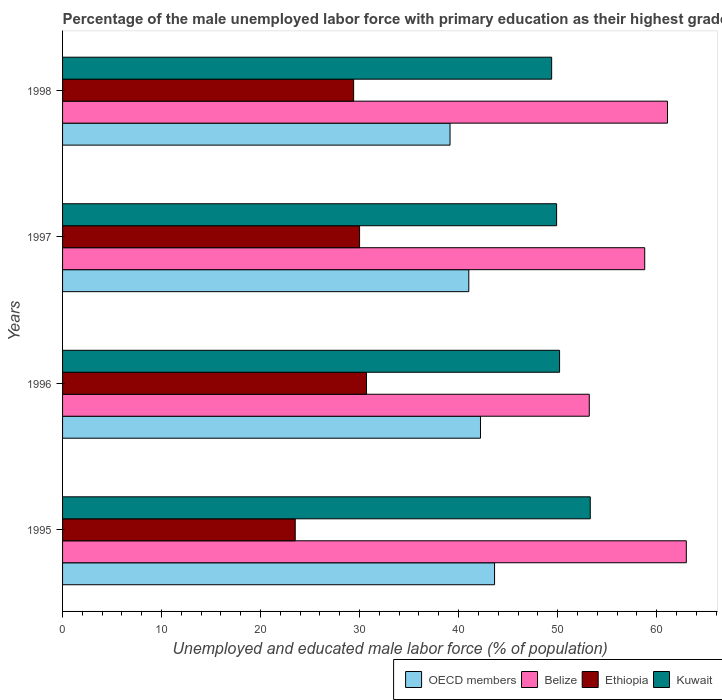Are the number of bars on each tick of the Y-axis equal?
Offer a very short reply. Yes. How many bars are there on the 3rd tick from the bottom?
Make the answer very short. 4. Across all years, what is the maximum percentage of the unemployed male labor force with primary education in OECD members?
Provide a short and direct response. 43.63. Across all years, what is the minimum percentage of the unemployed male labor force with primary education in Belize?
Ensure brevity in your answer.  53.2. What is the total percentage of the unemployed male labor force with primary education in OECD members in the graph?
Your response must be concise. 166.01. What is the difference between the percentage of the unemployed male labor force with primary education in Belize in 1996 and that in 1998?
Provide a succinct answer. -7.9. What is the difference between the percentage of the unemployed male labor force with primary education in Ethiopia in 1995 and the percentage of the unemployed male labor force with primary education in Kuwait in 1998?
Provide a succinct answer. -25.9. What is the average percentage of the unemployed male labor force with primary education in Belize per year?
Make the answer very short. 59.02. In the year 1998, what is the difference between the percentage of the unemployed male labor force with primary education in Kuwait and percentage of the unemployed male labor force with primary education in Belize?
Your answer should be very brief. -11.7. What is the ratio of the percentage of the unemployed male labor force with primary education in Kuwait in 1995 to that in 1996?
Your answer should be very brief. 1.06. What is the difference between the highest and the second highest percentage of the unemployed male labor force with primary education in OECD members?
Your answer should be very brief. 1.42. What is the difference between the highest and the lowest percentage of the unemployed male labor force with primary education in Kuwait?
Make the answer very short. 3.9. Is the sum of the percentage of the unemployed male labor force with primary education in Ethiopia in 1995 and 1997 greater than the maximum percentage of the unemployed male labor force with primary education in OECD members across all years?
Give a very brief answer. Yes. Is it the case that in every year, the sum of the percentage of the unemployed male labor force with primary education in Kuwait and percentage of the unemployed male labor force with primary education in Belize is greater than the sum of percentage of the unemployed male labor force with primary education in Ethiopia and percentage of the unemployed male labor force with primary education in OECD members?
Offer a very short reply. No. What does the 3rd bar from the top in 1998 represents?
Your answer should be very brief. Belize. What does the 1st bar from the bottom in 1998 represents?
Offer a very short reply. OECD members. Where does the legend appear in the graph?
Provide a short and direct response. Bottom right. What is the title of the graph?
Your answer should be compact. Percentage of the male unemployed labor force with primary education as their highest grade. Does "Georgia" appear as one of the legend labels in the graph?
Offer a terse response. No. What is the label or title of the X-axis?
Offer a terse response. Unemployed and educated male labor force (% of population). What is the label or title of the Y-axis?
Provide a short and direct response. Years. What is the Unemployed and educated male labor force (% of population) of OECD members in 1995?
Give a very brief answer. 43.63. What is the Unemployed and educated male labor force (% of population) of Kuwait in 1995?
Provide a short and direct response. 53.3. What is the Unemployed and educated male labor force (% of population) of OECD members in 1996?
Keep it short and to the point. 42.21. What is the Unemployed and educated male labor force (% of population) in Belize in 1996?
Provide a succinct answer. 53.2. What is the Unemployed and educated male labor force (% of population) in Ethiopia in 1996?
Provide a short and direct response. 30.7. What is the Unemployed and educated male labor force (% of population) of Kuwait in 1996?
Your response must be concise. 50.2. What is the Unemployed and educated male labor force (% of population) of OECD members in 1997?
Give a very brief answer. 41.03. What is the Unemployed and educated male labor force (% of population) of Belize in 1997?
Keep it short and to the point. 58.8. What is the Unemployed and educated male labor force (% of population) of Kuwait in 1997?
Keep it short and to the point. 49.9. What is the Unemployed and educated male labor force (% of population) in OECD members in 1998?
Provide a succinct answer. 39.14. What is the Unemployed and educated male labor force (% of population) of Belize in 1998?
Offer a very short reply. 61.1. What is the Unemployed and educated male labor force (% of population) of Ethiopia in 1998?
Keep it short and to the point. 29.4. What is the Unemployed and educated male labor force (% of population) in Kuwait in 1998?
Offer a very short reply. 49.4. Across all years, what is the maximum Unemployed and educated male labor force (% of population) in OECD members?
Provide a succinct answer. 43.63. Across all years, what is the maximum Unemployed and educated male labor force (% of population) in Ethiopia?
Keep it short and to the point. 30.7. Across all years, what is the maximum Unemployed and educated male labor force (% of population) of Kuwait?
Offer a very short reply. 53.3. Across all years, what is the minimum Unemployed and educated male labor force (% of population) in OECD members?
Ensure brevity in your answer.  39.14. Across all years, what is the minimum Unemployed and educated male labor force (% of population) of Belize?
Your answer should be compact. 53.2. Across all years, what is the minimum Unemployed and educated male labor force (% of population) in Ethiopia?
Offer a terse response. 23.5. Across all years, what is the minimum Unemployed and educated male labor force (% of population) in Kuwait?
Your answer should be compact. 49.4. What is the total Unemployed and educated male labor force (% of population) of OECD members in the graph?
Your response must be concise. 166.01. What is the total Unemployed and educated male labor force (% of population) in Belize in the graph?
Provide a short and direct response. 236.1. What is the total Unemployed and educated male labor force (% of population) of Ethiopia in the graph?
Make the answer very short. 113.6. What is the total Unemployed and educated male labor force (% of population) in Kuwait in the graph?
Offer a very short reply. 202.8. What is the difference between the Unemployed and educated male labor force (% of population) of OECD members in 1995 and that in 1996?
Give a very brief answer. 1.42. What is the difference between the Unemployed and educated male labor force (% of population) of Belize in 1995 and that in 1996?
Your response must be concise. 9.8. What is the difference between the Unemployed and educated male labor force (% of population) in OECD members in 1995 and that in 1997?
Your response must be concise. 2.6. What is the difference between the Unemployed and educated male labor force (% of population) of Kuwait in 1995 and that in 1997?
Keep it short and to the point. 3.4. What is the difference between the Unemployed and educated male labor force (% of population) of OECD members in 1995 and that in 1998?
Provide a short and direct response. 4.5. What is the difference between the Unemployed and educated male labor force (% of population) of Belize in 1995 and that in 1998?
Offer a terse response. 1.9. What is the difference between the Unemployed and educated male labor force (% of population) of OECD members in 1996 and that in 1997?
Keep it short and to the point. 1.18. What is the difference between the Unemployed and educated male labor force (% of population) of Ethiopia in 1996 and that in 1997?
Ensure brevity in your answer.  0.7. What is the difference between the Unemployed and educated male labor force (% of population) of OECD members in 1996 and that in 1998?
Your answer should be very brief. 3.07. What is the difference between the Unemployed and educated male labor force (% of population) of Belize in 1996 and that in 1998?
Your answer should be compact. -7.9. What is the difference between the Unemployed and educated male labor force (% of population) of Ethiopia in 1996 and that in 1998?
Your response must be concise. 1.3. What is the difference between the Unemployed and educated male labor force (% of population) in Kuwait in 1996 and that in 1998?
Provide a short and direct response. 0.8. What is the difference between the Unemployed and educated male labor force (% of population) in OECD members in 1997 and that in 1998?
Your answer should be compact. 1.89. What is the difference between the Unemployed and educated male labor force (% of population) of Ethiopia in 1997 and that in 1998?
Offer a terse response. 0.6. What is the difference between the Unemployed and educated male labor force (% of population) of Kuwait in 1997 and that in 1998?
Your answer should be compact. 0.5. What is the difference between the Unemployed and educated male labor force (% of population) of OECD members in 1995 and the Unemployed and educated male labor force (% of population) of Belize in 1996?
Your answer should be compact. -9.57. What is the difference between the Unemployed and educated male labor force (% of population) in OECD members in 1995 and the Unemployed and educated male labor force (% of population) in Ethiopia in 1996?
Your answer should be very brief. 12.93. What is the difference between the Unemployed and educated male labor force (% of population) in OECD members in 1995 and the Unemployed and educated male labor force (% of population) in Kuwait in 1996?
Give a very brief answer. -6.57. What is the difference between the Unemployed and educated male labor force (% of population) of Belize in 1995 and the Unemployed and educated male labor force (% of population) of Ethiopia in 1996?
Give a very brief answer. 32.3. What is the difference between the Unemployed and educated male labor force (% of population) of Ethiopia in 1995 and the Unemployed and educated male labor force (% of population) of Kuwait in 1996?
Your answer should be compact. -26.7. What is the difference between the Unemployed and educated male labor force (% of population) in OECD members in 1995 and the Unemployed and educated male labor force (% of population) in Belize in 1997?
Offer a very short reply. -15.17. What is the difference between the Unemployed and educated male labor force (% of population) of OECD members in 1995 and the Unemployed and educated male labor force (% of population) of Ethiopia in 1997?
Provide a succinct answer. 13.63. What is the difference between the Unemployed and educated male labor force (% of population) of OECD members in 1995 and the Unemployed and educated male labor force (% of population) of Kuwait in 1997?
Offer a very short reply. -6.27. What is the difference between the Unemployed and educated male labor force (% of population) of Belize in 1995 and the Unemployed and educated male labor force (% of population) of Ethiopia in 1997?
Your answer should be very brief. 33. What is the difference between the Unemployed and educated male labor force (% of population) of Belize in 1995 and the Unemployed and educated male labor force (% of population) of Kuwait in 1997?
Your answer should be very brief. 13.1. What is the difference between the Unemployed and educated male labor force (% of population) of Ethiopia in 1995 and the Unemployed and educated male labor force (% of population) of Kuwait in 1997?
Provide a short and direct response. -26.4. What is the difference between the Unemployed and educated male labor force (% of population) of OECD members in 1995 and the Unemployed and educated male labor force (% of population) of Belize in 1998?
Provide a succinct answer. -17.47. What is the difference between the Unemployed and educated male labor force (% of population) of OECD members in 1995 and the Unemployed and educated male labor force (% of population) of Ethiopia in 1998?
Your response must be concise. 14.23. What is the difference between the Unemployed and educated male labor force (% of population) of OECD members in 1995 and the Unemployed and educated male labor force (% of population) of Kuwait in 1998?
Offer a very short reply. -5.77. What is the difference between the Unemployed and educated male labor force (% of population) in Belize in 1995 and the Unemployed and educated male labor force (% of population) in Ethiopia in 1998?
Give a very brief answer. 33.6. What is the difference between the Unemployed and educated male labor force (% of population) in Ethiopia in 1995 and the Unemployed and educated male labor force (% of population) in Kuwait in 1998?
Your answer should be compact. -25.9. What is the difference between the Unemployed and educated male labor force (% of population) of OECD members in 1996 and the Unemployed and educated male labor force (% of population) of Belize in 1997?
Provide a succinct answer. -16.59. What is the difference between the Unemployed and educated male labor force (% of population) of OECD members in 1996 and the Unemployed and educated male labor force (% of population) of Ethiopia in 1997?
Provide a succinct answer. 12.21. What is the difference between the Unemployed and educated male labor force (% of population) in OECD members in 1996 and the Unemployed and educated male labor force (% of population) in Kuwait in 1997?
Make the answer very short. -7.69. What is the difference between the Unemployed and educated male labor force (% of population) in Belize in 1996 and the Unemployed and educated male labor force (% of population) in Ethiopia in 1997?
Your answer should be very brief. 23.2. What is the difference between the Unemployed and educated male labor force (% of population) in Ethiopia in 1996 and the Unemployed and educated male labor force (% of population) in Kuwait in 1997?
Ensure brevity in your answer.  -19.2. What is the difference between the Unemployed and educated male labor force (% of population) in OECD members in 1996 and the Unemployed and educated male labor force (% of population) in Belize in 1998?
Offer a very short reply. -18.89. What is the difference between the Unemployed and educated male labor force (% of population) of OECD members in 1996 and the Unemployed and educated male labor force (% of population) of Ethiopia in 1998?
Keep it short and to the point. 12.81. What is the difference between the Unemployed and educated male labor force (% of population) in OECD members in 1996 and the Unemployed and educated male labor force (% of population) in Kuwait in 1998?
Your answer should be very brief. -7.19. What is the difference between the Unemployed and educated male labor force (% of population) of Belize in 1996 and the Unemployed and educated male labor force (% of population) of Ethiopia in 1998?
Ensure brevity in your answer.  23.8. What is the difference between the Unemployed and educated male labor force (% of population) in Ethiopia in 1996 and the Unemployed and educated male labor force (% of population) in Kuwait in 1998?
Your answer should be compact. -18.7. What is the difference between the Unemployed and educated male labor force (% of population) of OECD members in 1997 and the Unemployed and educated male labor force (% of population) of Belize in 1998?
Your answer should be very brief. -20.07. What is the difference between the Unemployed and educated male labor force (% of population) in OECD members in 1997 and the Unemployed and educated male labor force (% of population) in Ethiopia in 1998?
Give a very brief answer. 11.63. What is the difference between the Unemployed and educated male labor force (% of population) of OECD members in 1997 and the Unemployed and educated male labor force (% of population) of Kuwait in 1998?
Provide a short and direct response. -8.37. What is the difference between the Unemployed and educated male labor force (% of population) in Belize in 1997 and the Unemployed and educated male labor force (% of population) in Ethiopia in 1998?
Ensure brevity in your answer.  29.4. What is the difference between the Unemployed and educated male labor force (% of population) in Belize in 1997 and the Unemployed and educated male labor force (% of population) in Kuwait in 1998?
Make the answer very short. 9.4. What is the difference between the Unemployed and educated male labor force (% of population) in Ethiopia in 1997 and the Unemployed and educated male labor force (% of population) in Kuwait in 1998?
Provide a succinct answer. -19.4. What is the average Unemployed and educated male labor force (% of population) in OECD members per year?
Provide a succinct answer. 41.5. What is the average Unemployed and educated male labor force (% of population) in Belize per year?
Keep it short and to the point. 59.02. What is the average Unemployed and educated male labor force (% of population) in Ethiopia per year?
Offer a terse response. 28.4. What is the average Unemployed and educated male labor force (% of population) in Kuwait per year?
Your response must be concise. 50.7. In the year 1995, what is the difference between the Unemployed and educated male labor force (% of population) of OECD members and Unemployed and educated male labor force (% of population) of Belize?
Ensure brevity in your answer.  -19.37. In the year 1995, what is the difference between the Unemployed and educated male labor force (% of population) of OECD members and Unemployed and educated male labor force (% of population) of Ethiopia?
Ensure brevity in your answer.  20.13. In the year 1995, what is the difference between the Unemployed and educated male labor force (% of population) of OECD members and Unemployed and educated male labor force (% of population) of Kuwait?
Make the answer very short. -9.67. In the year 1995, what is the difference between the Unemployed and educated male labor force (% of population) of Belize and Unemployed and educated male labor force (% of population) of Ethiopia?
Ensure brevity in your answer.  39.5. In the year 1995, what is the difference between the Unemployed and educated male labor force (% of population) of Belize and Unemployed and educated male labor force (% of population) of Kuwait?
Your response must be concise. 9.7. In the year 1995, what is the difference between the Unemployed and educated male labor force (% of population) of Ethiopia and Unemployed and educated male labor force (% of population) of Kuwait?
Offer a very short reply. -29.8. In the year 1996, what is the difference between the Unemployed and educated male labor force (% of population) in OECD members and Unemployed and educated male labor force (% of population) in Belize?
Give a very brief answer. -10.99. In the year 1996, what is the difference between the Unemployed and educated male labor force (% of population) in OECD members and Unemployed and educated male labor force (% of population) in Ethiopia?
Provide a short and direct response. 11.51. In the year 1996, what is the difference between the Unemployed and educated male labor force (% of population) of OECD members and Unemployed and educated male labor force (% of population) of Kuwait?
Provide a succinct answer. -7.99. In the year 1996, what is the difference between the Unemployed and educated male labor force (% of population) of Belize and Unemployed and educated male labor force (% of population) of Ethiopia?
Ensure brevity in your answer.  22.5. In the year 1996, what is the difference between the Unemployed and educated male labor force (% of population) in Belize and Unemployed and educated male labor force (% of population) in Kuwait?
Provide a succinct answer. 3. In the year 1996, what is the difference between the Unemployed and educated male labor force (% of population) in Ethiopia and Unemployed and educated male labor force (% of population) in Kuwait?
Provide a succinct answer. -19.5. In the year 1997, what is the difference between the Unemployed and educated male labor force (% of population) in OECD members and Unemployed and educated male labor force (% of population) in Belize?
Provide a short and direct response. -17.77. In the year 1997, what is the difference between the Unemployed and educated male labor force (% of population) in OECD members and Unemployed and educated male labor force (% of population) in Ethiopia?
Keep it short and to the point. 11.03. In the year 1997, what is the difference between the Unemployed and educated male labor force (% of population) in OECD members and Unemployed and educated male labor force (% of population) in Kuwait?
Offer a terse response. -8.87. In the year 1997, what is the difference between the Unemployed and educated male labor force (% of population) of Belize and Unemployed and educated male labor force (% of population) of Ethiopia?
Your answer should be compact. 28.8. In the year 1997, what is the difference between the Unemployed and educated male labor force (% of population) of Belize and Unemployed and educated male labor force (% of population) of Kuwait?
Ensure brevity in your answer.  8.9. In the year 1997, what is the difference between the Unemployed and educated male labor force (% of population) in Ethiopia and Unemployed and educated male labor force (% of population) in Kuwait?
Your response must be concise. -19.9. In the year 1998, what is the difference between the Unemployed and educated male labor force (% of population) of OECD members and Unemployed and educated male labor force (% of population) of Belize?
Keep it short and to the point. -21.96. In the year 1998, what is the difference between the Unemployed and educated male labor force (% of population) of OECD members and Unemployed and educated male labor force (% of population) of Ethiopia?
Offer a very short reply. 9.74. In the year 1998, what is the difference between the Unemployed and educated male labor force (% of population) of OECD members and Unemployed and educated male labor force (% of population) of Kuwait?
Ensure brevity in your answer.  -10.26. In the year 1998, what is the difference between the Unemployed and educated male labor force (% of population) of Belize and Unemployed and educated male labor force (% of population) of Ethiopia?
Your answer should be very brief. 31.7. In the year 1998, what is the difference between the Unemployed and educated male labor force (% of population) in Belize and Unemployed and educated male labor force (% of population) in Kuwait?
Ensure brevity in your answer.  11.7. What is the ratio of the Unemployed and educated male labor force (% of population) in OECD members in 1995 to that in 1996?
Offer a terse response. 1.03. What is the ratio of the Unemployed and educated male labor force (% of population) in Belize in 1995 to that in 1996?
Your answer should be very brief. 1.18. What is the ratio of the Unemployed and educated male labor force (% of population) in Ethiopia in 1995 to that in 1996?
Offer a terse response. 0.77. What is the ratio of the Unemployed and educated male labor force (% of population) in Kuwait in 1995 to that in 1996?
Give a very brief answer. 1.06. What is the ratio of the Unemployed and educated male labor force (% of population) in OECD members in 1995 to that in 1997?
Provide a short and direct response. 1.06. What is the ratio of the Unemployed and educated male labor force (% of population) of Belize in 1995 to that in 1997?
Keep it short and to the point. 1.07. What is the ratio of the Unemployed and educated male labor force (% of population) of Ethiopia in 1995 to that in 1997?
Provide a succinct answer. 0.78. What is the ratio of the Unemployed and educated male labor force (% of population) in Kuwait in 1995 to that in 1997?
Offer a very short reply. 1.07. What is the ratio of the Unemployed and educated male labor force (% of population) of OECD members in 1995 to that in 1998?
Ensure brevity in your answer.  1.11. What is the ratio of the Unemployed and educated male labor force (% of population) in Belize in 1995 to that in 1998?
Offer a very short reply. 1.03. What is the ratio of the Unemployed and educated male labor force (% of population) in Ethiopia in 1995 to that in 1998?
Ensure brevity in your answer.  0.8. What is the ratio of the Unemployed and educated male labor force (% of population) of Kuwait in 1995 to that in 1998?
Make the answer very short. 1.08. What is the ratio of the Unemployed and educated male labor force (% of population) of OECD members in 1996 to that in 1997?
Keep it short and to the point. 1.03. What is the ratio of the Unemployed and educated male labor force (% of population) of Belize in 1996 to that in 1997?
Your answer should be very brief. 0.9. What is the ratio of the Unemployed and educated male labor force (% of population) in Ethiopia in 1996 to that in 1997?
Provide a succinct answer. 1.02. What is the ratio of the Unemployed and educated male labor force (% of population) in Kuwait in 1996 to that in 1997?
Ensure brevity in your answer.  1.01. What is the ratio of the Unemployed and educated male labor force (% of population) in OECD members in 1996 to that in 1998?
Ensure brevity in your answer.  1.08. What is the ratio of the Unemployed and educated male labor force (% of population) of Belize in 1996 to that in 1998?
Provide a succinct answer. 0.87. What is the ratio of the Unemployed and educated male labor force (% of population) of Ethiopia in 1996 to that in 1998?
Ensure brevity in your answer.  1.04. What is the ratio of the Unemployed and educated male labor force (% of population) in Kuwait in 1996 to that in 1998?
Give a very brief answer. 1.02. What is the ratio of the Unemployed and educated male labor force (% of population) in OECD members in 1997 to that in 1998?
Give a very brief answer. 1.05. What is the ratio of the Unemployed and educated male labor force (% of population) of Belize in 1997 to that in 1998?
Ensure brevity in your answer.  0.96. What is the ratio of the Unemployed and educated male labor force (% of population) of Ethiopia in 1997 to that in 1998?
Offer a very short reply. 1.02. What is the ratio of the Unemployed and educated male labor force (% of population) in Kuwait in 1997 to that in 1998?
Your response must be concise. 1.01. What is the difference between the highest and the second highest Unemployed and educated male labor force (% of population) in OECD members?
Keep it short and to the point. 1.42. What is the difference between the highest and the second highest Unemployed and educated male labor force (% of population) of Kuwait?
Make the answer very short. 3.1. What is the difference between the highest and the lowest Unemployed and educated male labor force (% of population) of OECD members?
Offer a terse response. 4.5. What is the difference between the highest and the lowest Unemployed and educated male labor force (% of population) of Kuwait?
Provide a short and direct response. 3.9. 